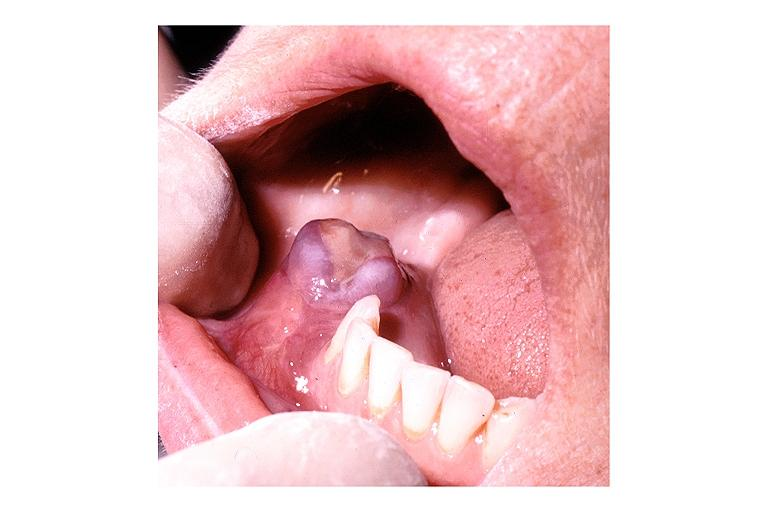what does this image show?
Answer the question using a single word or phrase. Hyperparathyroidism brown tumor 